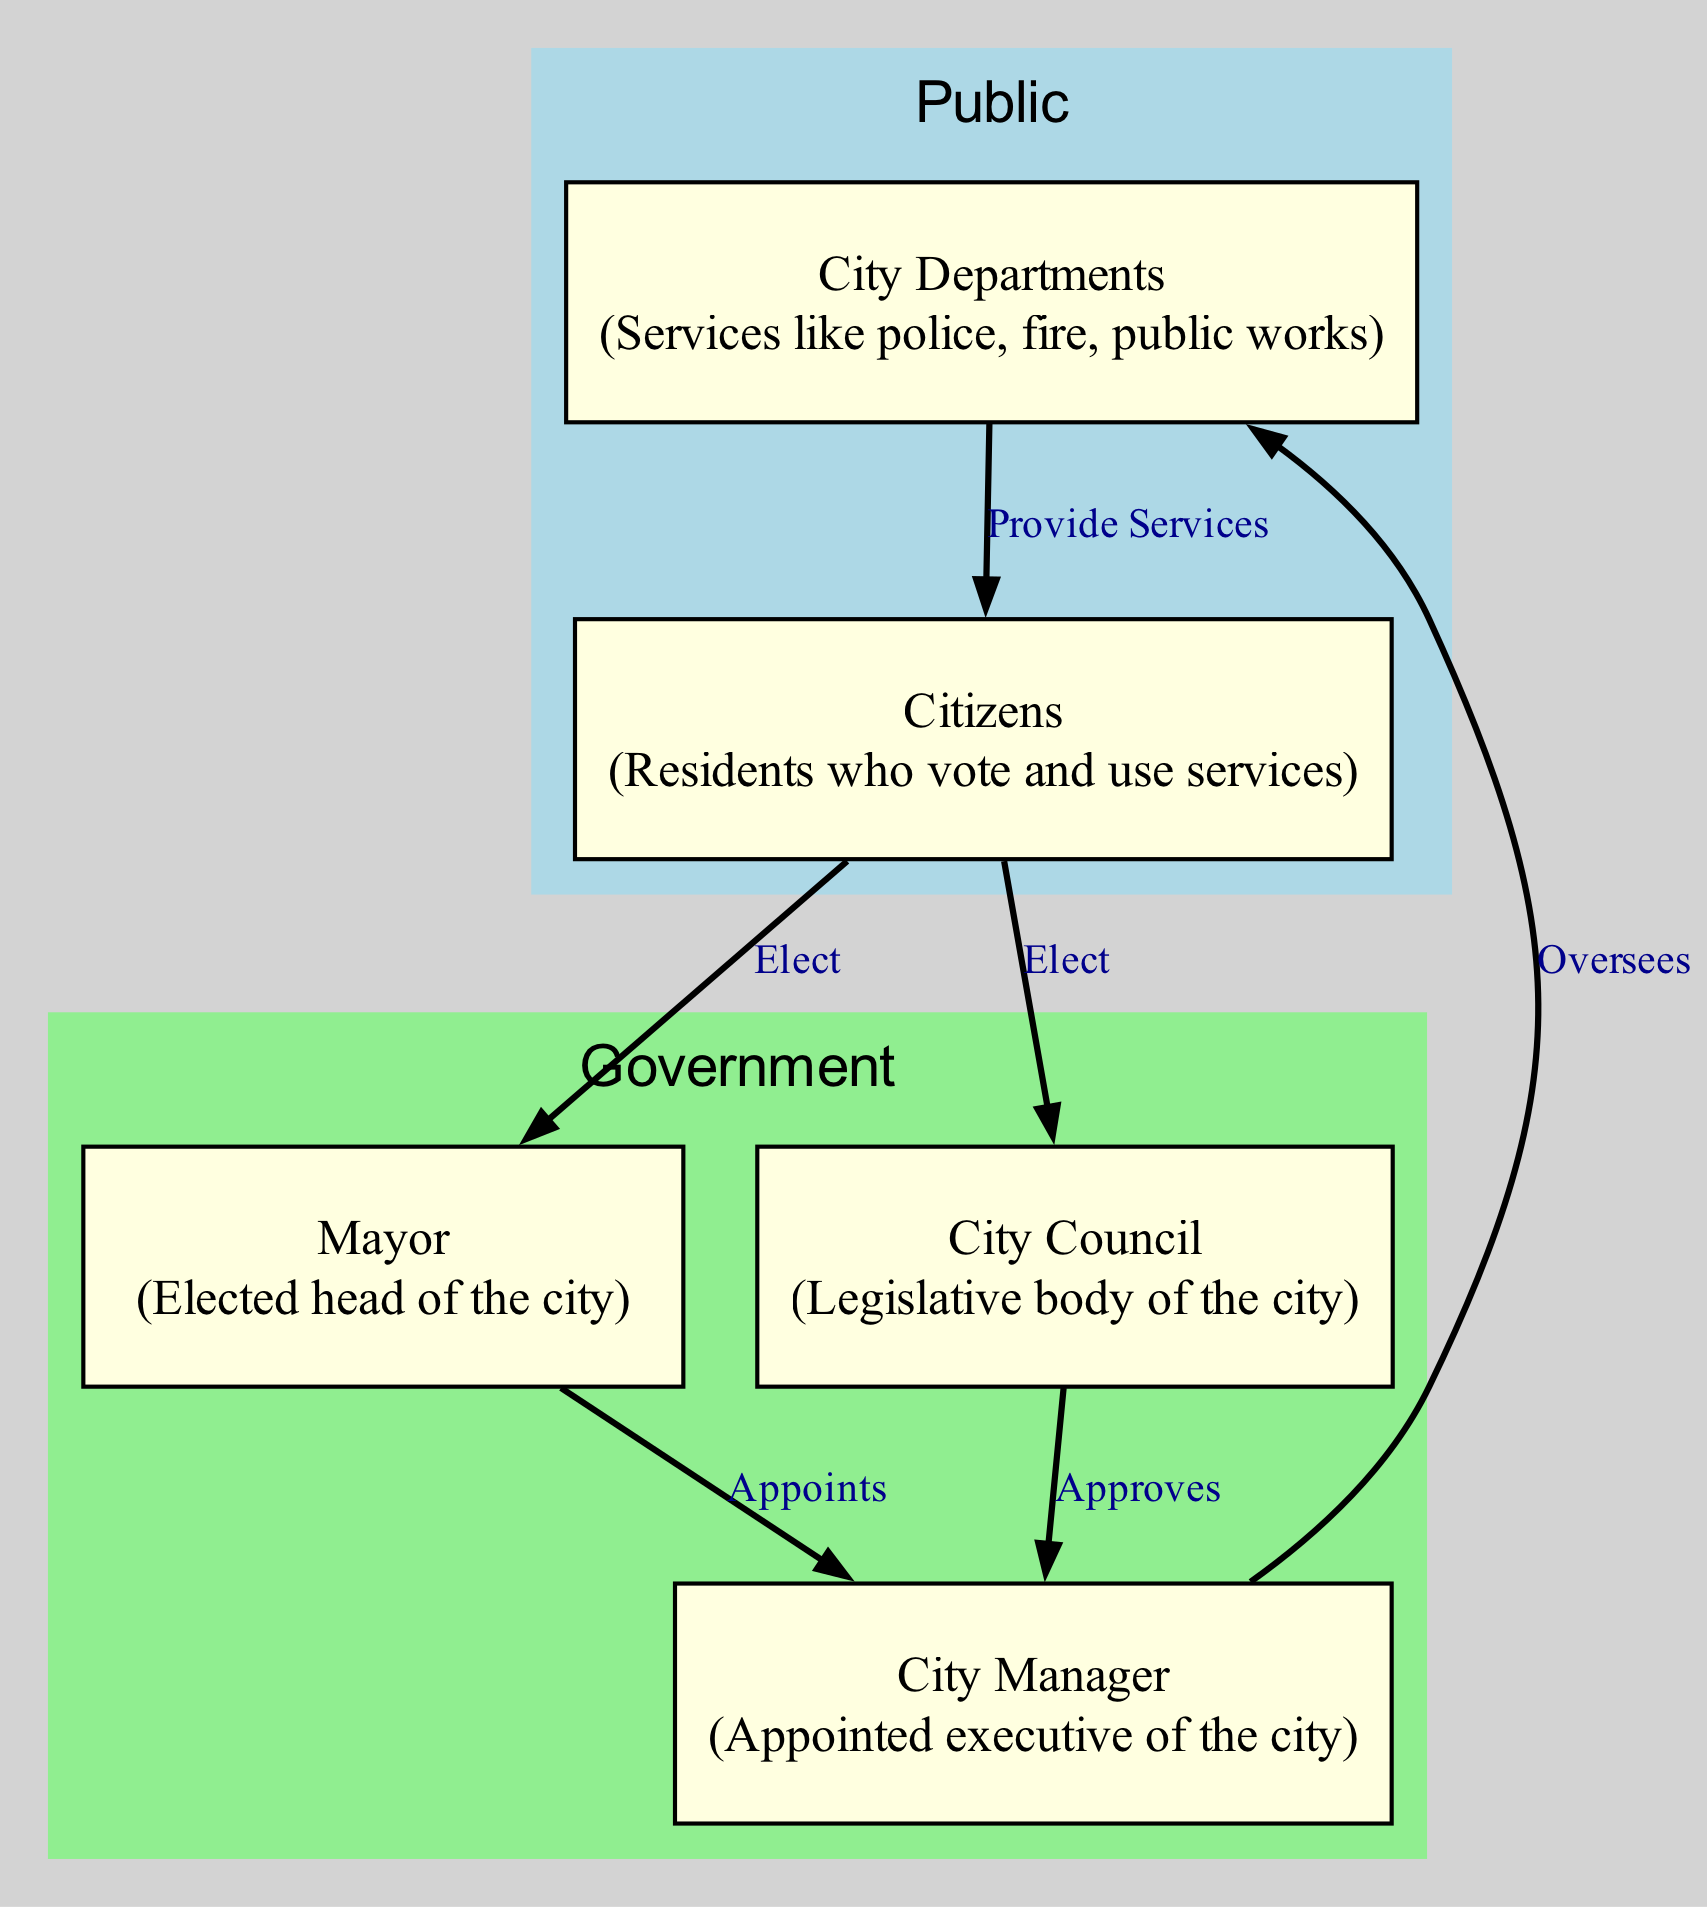What is the elected head of the city? The diagram shows the "Mayor" as the elected head of the city in the node labeled "Mayor". This is a direct description of the role based on the vocabulary provided in the diagram.
Answer: Mayor Who elects the City Council? The diagram indicates that "Citizens" are responsible for electing the "City Council" by showing an edge labeled "Elect" from "Citizens" to "City Council". This means that the citizens have the power to choose the council members.
Answer: Citizens How many main roles are in the local government structure? The diagram has five nodes: Mayor, City Council, City Manager, City Departments, and Citizens. Counting these, we find that there are five main roles represented visually in the structure.
Answer: Five What is the relationship between the City Manager and the City Departments? The diagram illustrates that the City Manager "Oversees" the City Departments, as indicated by the directional edge labeled "Oversees" connecting the City Manager node to the City Departments node. This indicates a managerial role.
Answer: Oversees Which two entities do Citizens elect? The diagram shows that Citizens elect both the Mayor and the City Council through edges labeled "Elect" connecting Citizens to these two entities. This portrays the direct involvement of citizens in selecting their representatives.
Answer: Mayor and City Council What role does the Mayor have in relation to the City Manager? According to the diagram, the Mayor "Appoints" the City Manager, indicated by an edge labeled "Appoints" connecting the Mayor to the City Manager. This underscores the Mayor's authority in selecting the executive leader.
Answer: Appoints What do City Departments provide to Citizens? The diagram indicates that City Departments "Provide Services" to Citizens, demonstrated by the edge labeled "Provide Services" from City Departments to Citizens. This describes the functional relationship of support offered by the departments.
Answer: Provide Services Which group is responsible for approving the City Manager? The diagram depicts that the City Council "Approves" the City Manager, as shown by the edge labeled "Approves" connecting City Council to City Manager. This is a critical responsibility of the Council in local governance.
Answer: City Council Who oversees the service delivery to Citizens in the local government? The City Manager oversees the City Departments, which in turn provide services to Citizens. By following the flow of the diagram, it is clear that the ultimate oversight of service delivery comes from the City Manager through the departments.
Answer: City Manager 